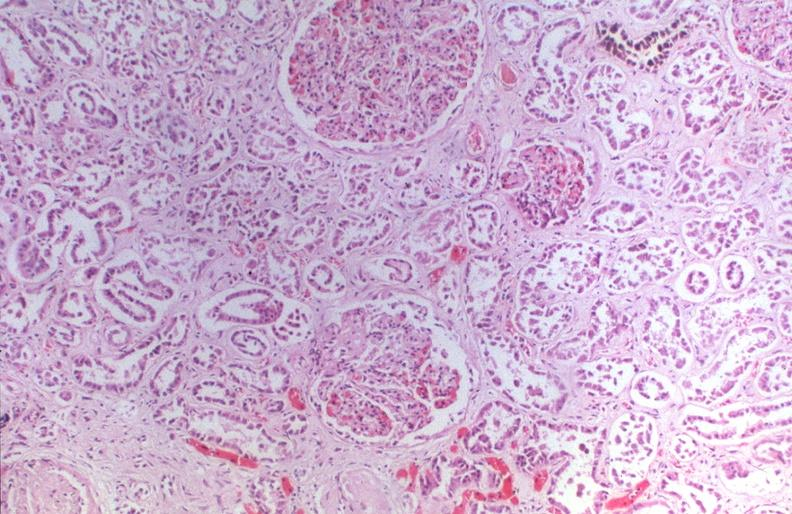where is this?
Answer the question using a single word or phrase. Urinary 